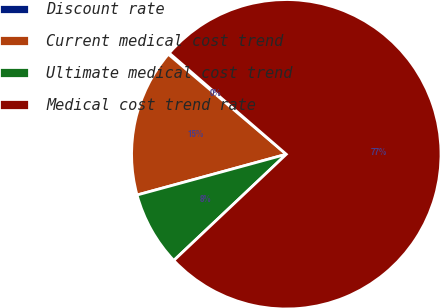Convert chart to OTSL. <chart><loc_0><loc_0><loc_500><loc_500><pie_chart><fcel>Discount rate<fcel>Current medical cost trend<fcel>Ultimate medical cost trend<fcel>Medical cost trend rate<nl><fcel>0.15%<fcel>15.44%<fcel>7.8%<fcel>76.61%<nl></chart> 